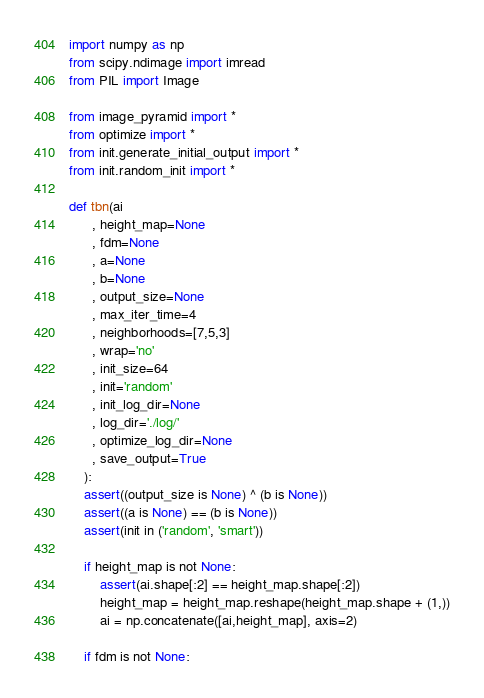Convert code to text. <code><loc_0><loc_0><loc_500><loc_500><_Python_>import numpy as np
from scipy.ndimage import imread
from PIL import Image

from image_pyramid import *
from optimize import *
from init.generate_initial_output import *
from init.random_init import *

def tbn(ai
      , height_map=None
      , fdm=None
      , a=None
      , b=None
      , output_size=None
      , max_iter_time=4
      , neighborhoods=[7,5,3]
      , wrap='no'
      , init_size=64
      , init='random'
      , init_log_dir=None
      , log_dir='./log/'
      , optimize_log_dir=None
      , save_output=True
    ):
    assert((output_size is None) ^ (b is None))
    assert((a is None) == (b is None))
    assert(init in ('random', 'smart'))

    if height_map is not None:
        assert(ai.shape[:2] == height_map.shape[:2])
        height_map = height_map.reshape(height_map.shape + (1,))
        ai = np.concatenate([ai,height_map], axis=2)

    if fdm is not None:</code> 